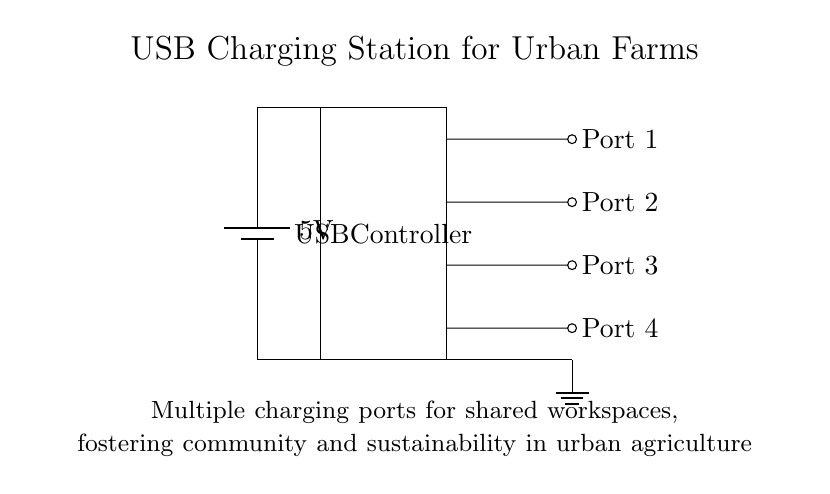What is the voltage of this circuit? The voltage is indicated as 5V next to the battery component in the circuit diagram, which provides the power source.
Answer: 5V What is the function of the USB controller? The USB controller is depicted as a rectangle in the diagram and is responsible for managing the connection and power distribution to the multiple output ports.
Answer: USB controller How many output ports are there in the circuit? The circuit diagram shows four output ports labeled Port 1, Port 2, Port 3, and Port 4, confirming that there are four ports available for charging.
Answer: Four What component supplies power to the circuit? The power source in the circuit is provided by the battery, which is labeled as a battery component in the diagram.
Answer: Battery What is the purpose of the short lines leading to the ports? The short lines indicate connections between the USB controller and the output ports, which allow the transfer of power from the controller to each port for charging devices.
Answer: Connections Which component is grounded in this circuit? The ground in the circuit is indicated at the bottom right of the diagram and shows that the USB controller's connection is grounded to complete the circuit.
Answer: Ground 